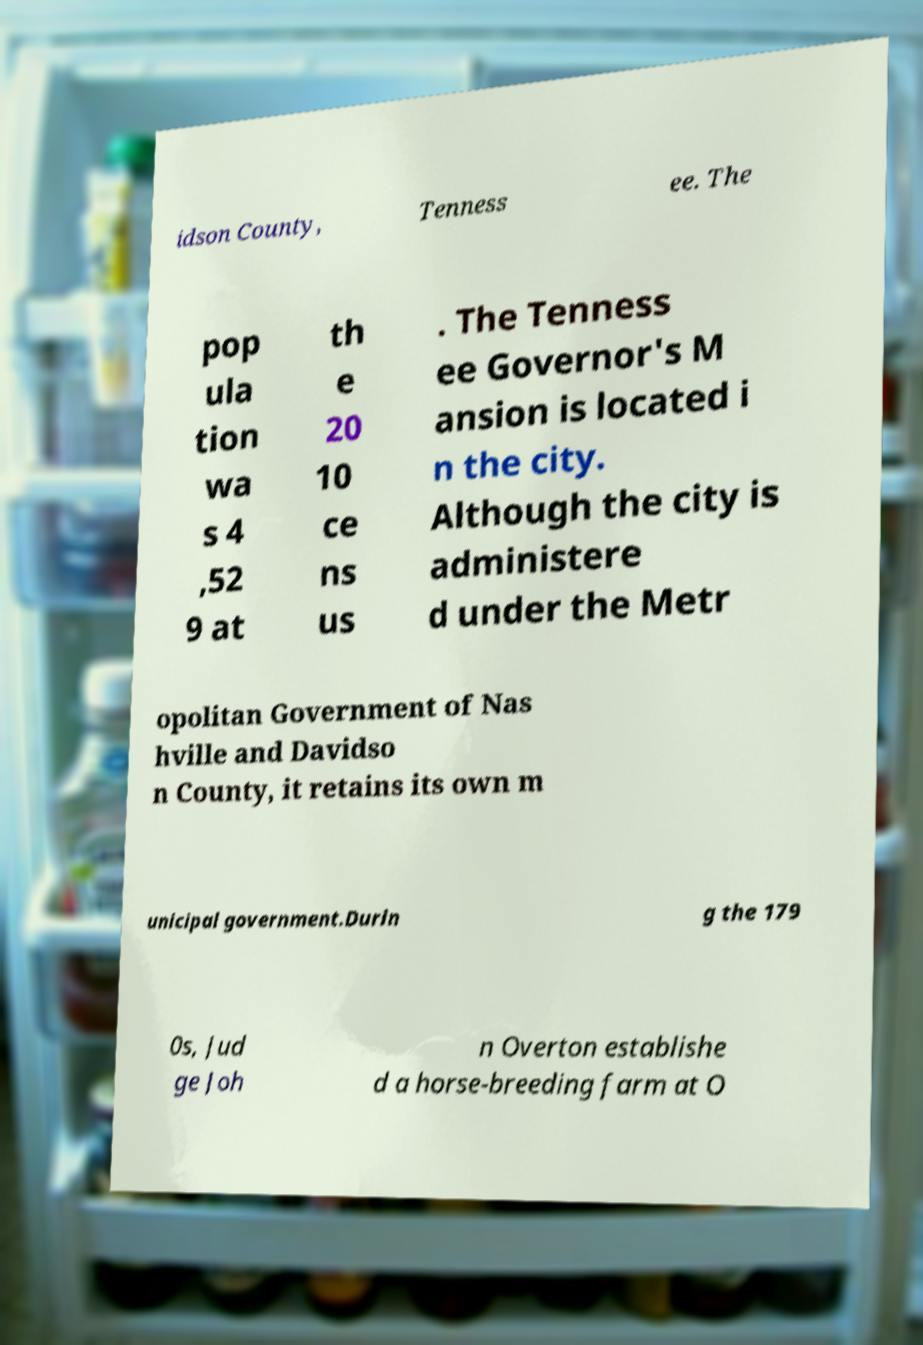Can you accurately transcribe the text from the provided image for me? idson County, Tenness ee. The pop ula tion wa s 4 ,52 9 at th e 20 10 ce ns us . The Tenness ee Governor's M ansion is located i n the city. Although the city is administere d under the Metr opolitan Government of Nas hville and Davidso n County, it retains its own m unicipal government.Durin g the 179 0s, Jud ge Joh n Overton establishe d a horse-breeding farm at O 